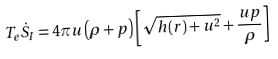Convert formula to latex. <formula><loc_0><loc_0><loc_500><loc_500>T _ { e } \dot { S } _ { I } = 4 \pi u \left ( \rho + p \right ) \left [ \sqrt { h ( r ) + u ^ { 2 } } + \frac { u p } { \rho } \right ]</formula> 